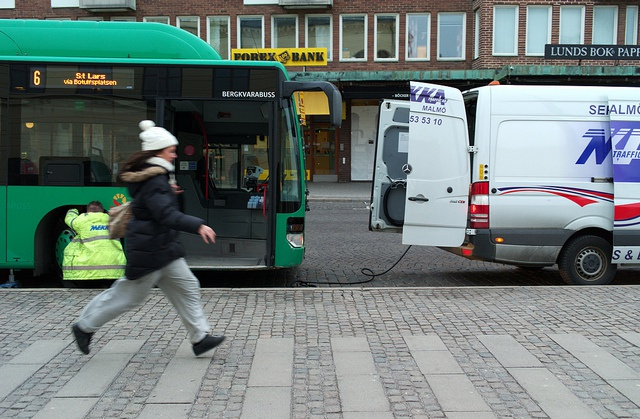Describe the objects in this image and their specific colors. I can see bus in lightblue, black, darkgreen, turquoise, and gray tones, truck in lightgray, lightblue, black, and gray tones, people in lightblue, black, gray, darkgray, and lightgray tones, people in lightblue, lightgreen, and olive tones, and handbag in lightblue, gray, black, and darkgray tones in this image. 